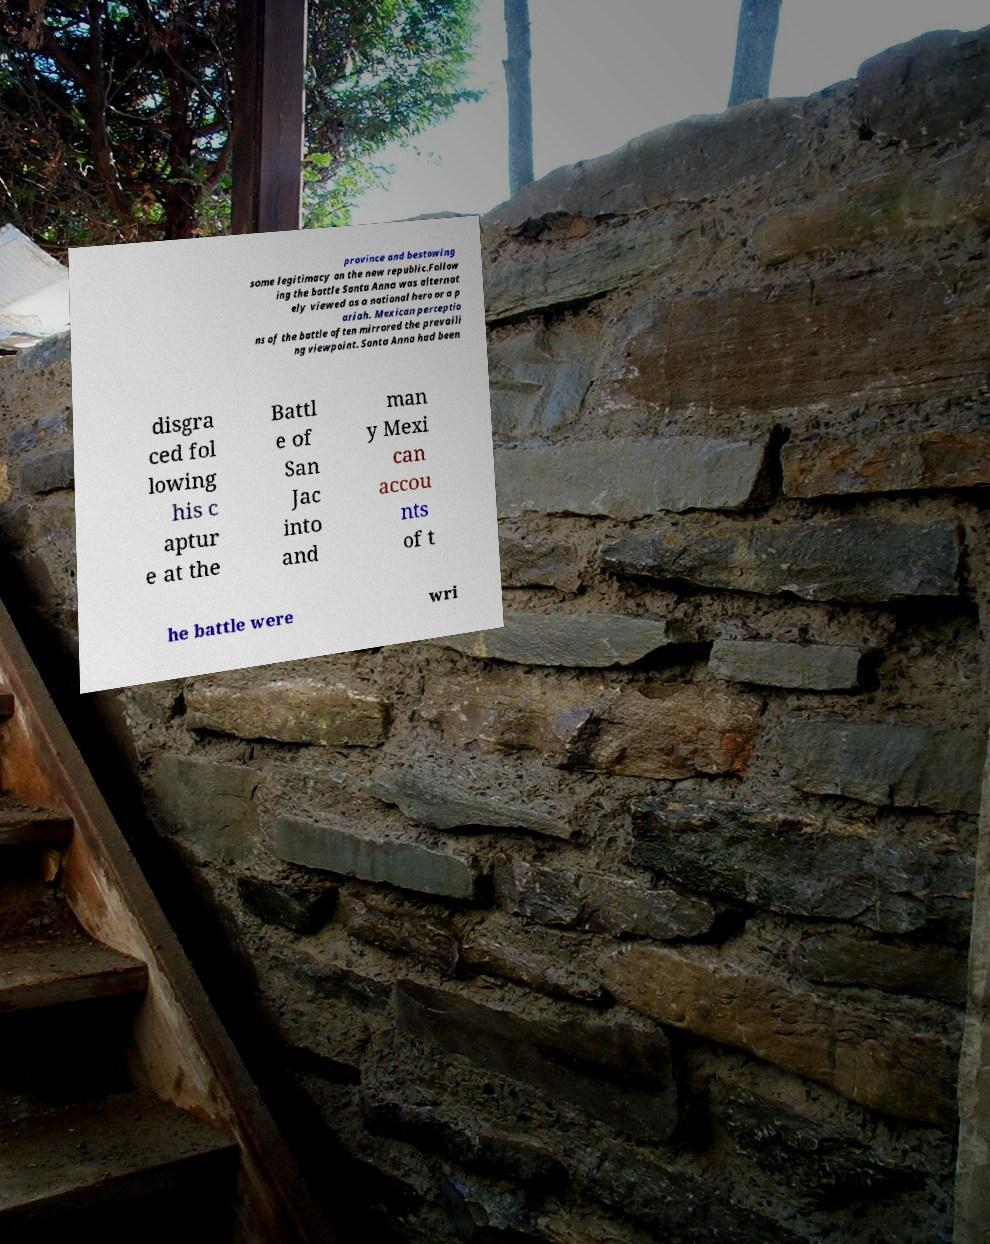There's text embedded in this image that I need extracted. Can you transcribe it verbatim? province and bestowing some legitimacy on the new republic.Follow ing the battle Santa Anna was alternat ely viewed as a national hero or a p ariah. Mexican perceptio ns of the battle often mirrored the prevaili ng viewpoint. Santa Anna had been disgra ced fol lowing his c aptur e at the Battl e of San Jac into and man y Mexi can accou nts of t he battle were wri 